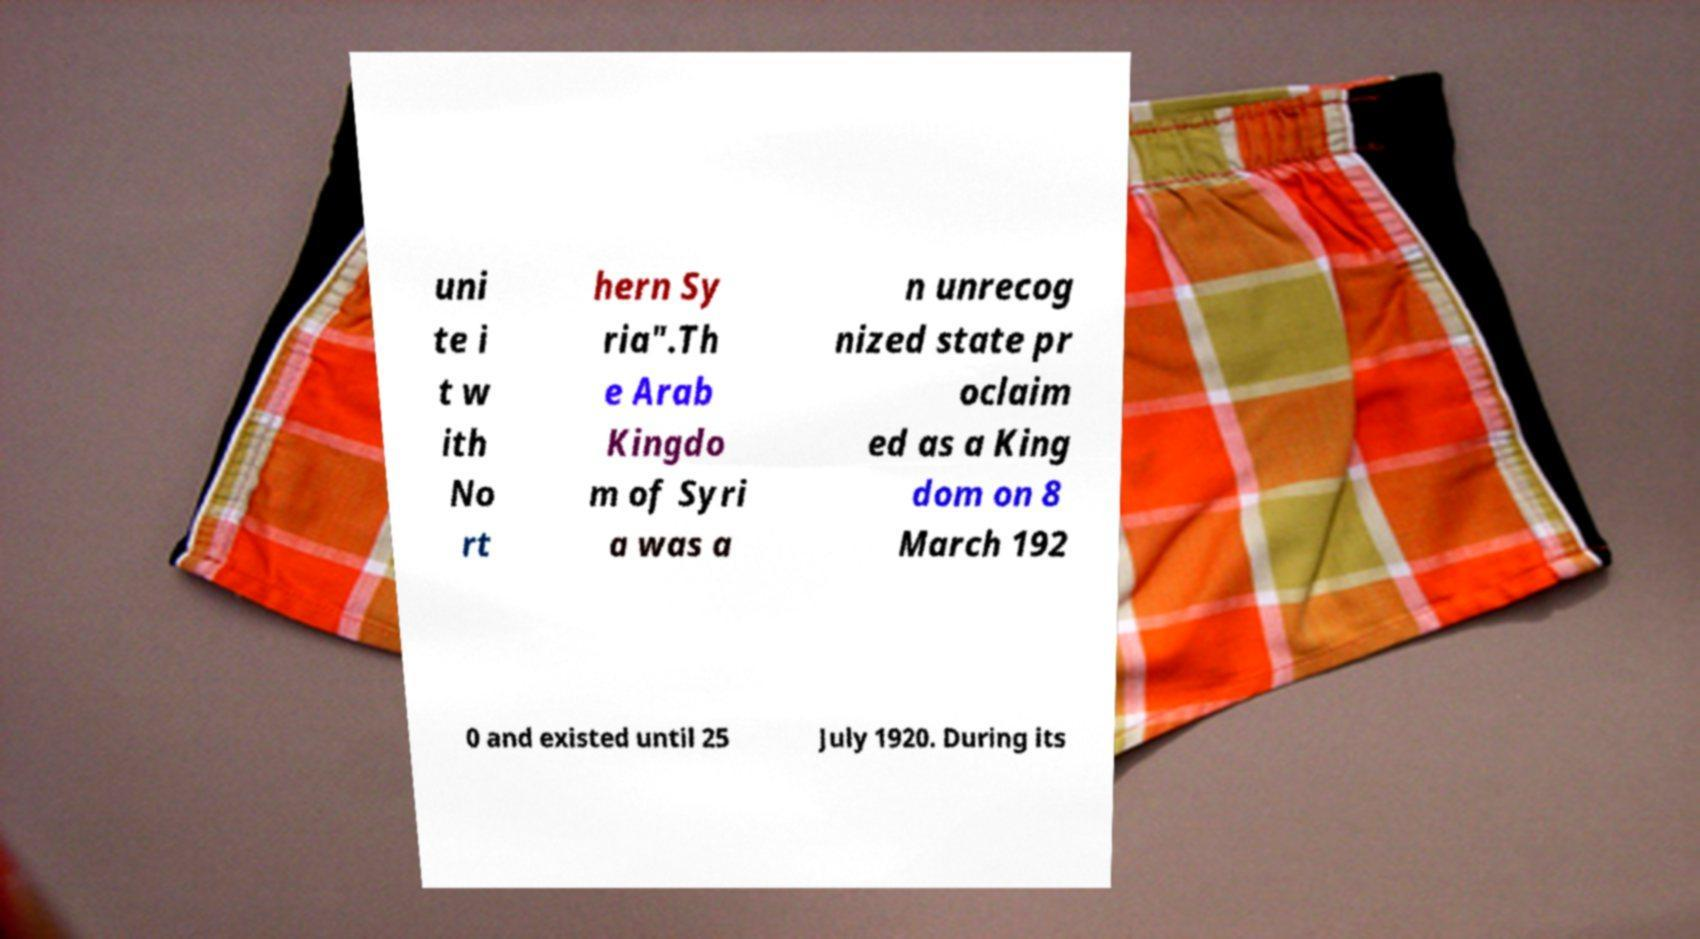I need the written content from this picture converted into text. Can you do that? uni te i t w ith No rt hern Sy ria".Th e Arab Kingdo m of Syri a was a n unrecog nized state pr oclaim ed as a King dom on 8 March 192 0 and existed until 25 July 1920. During its 